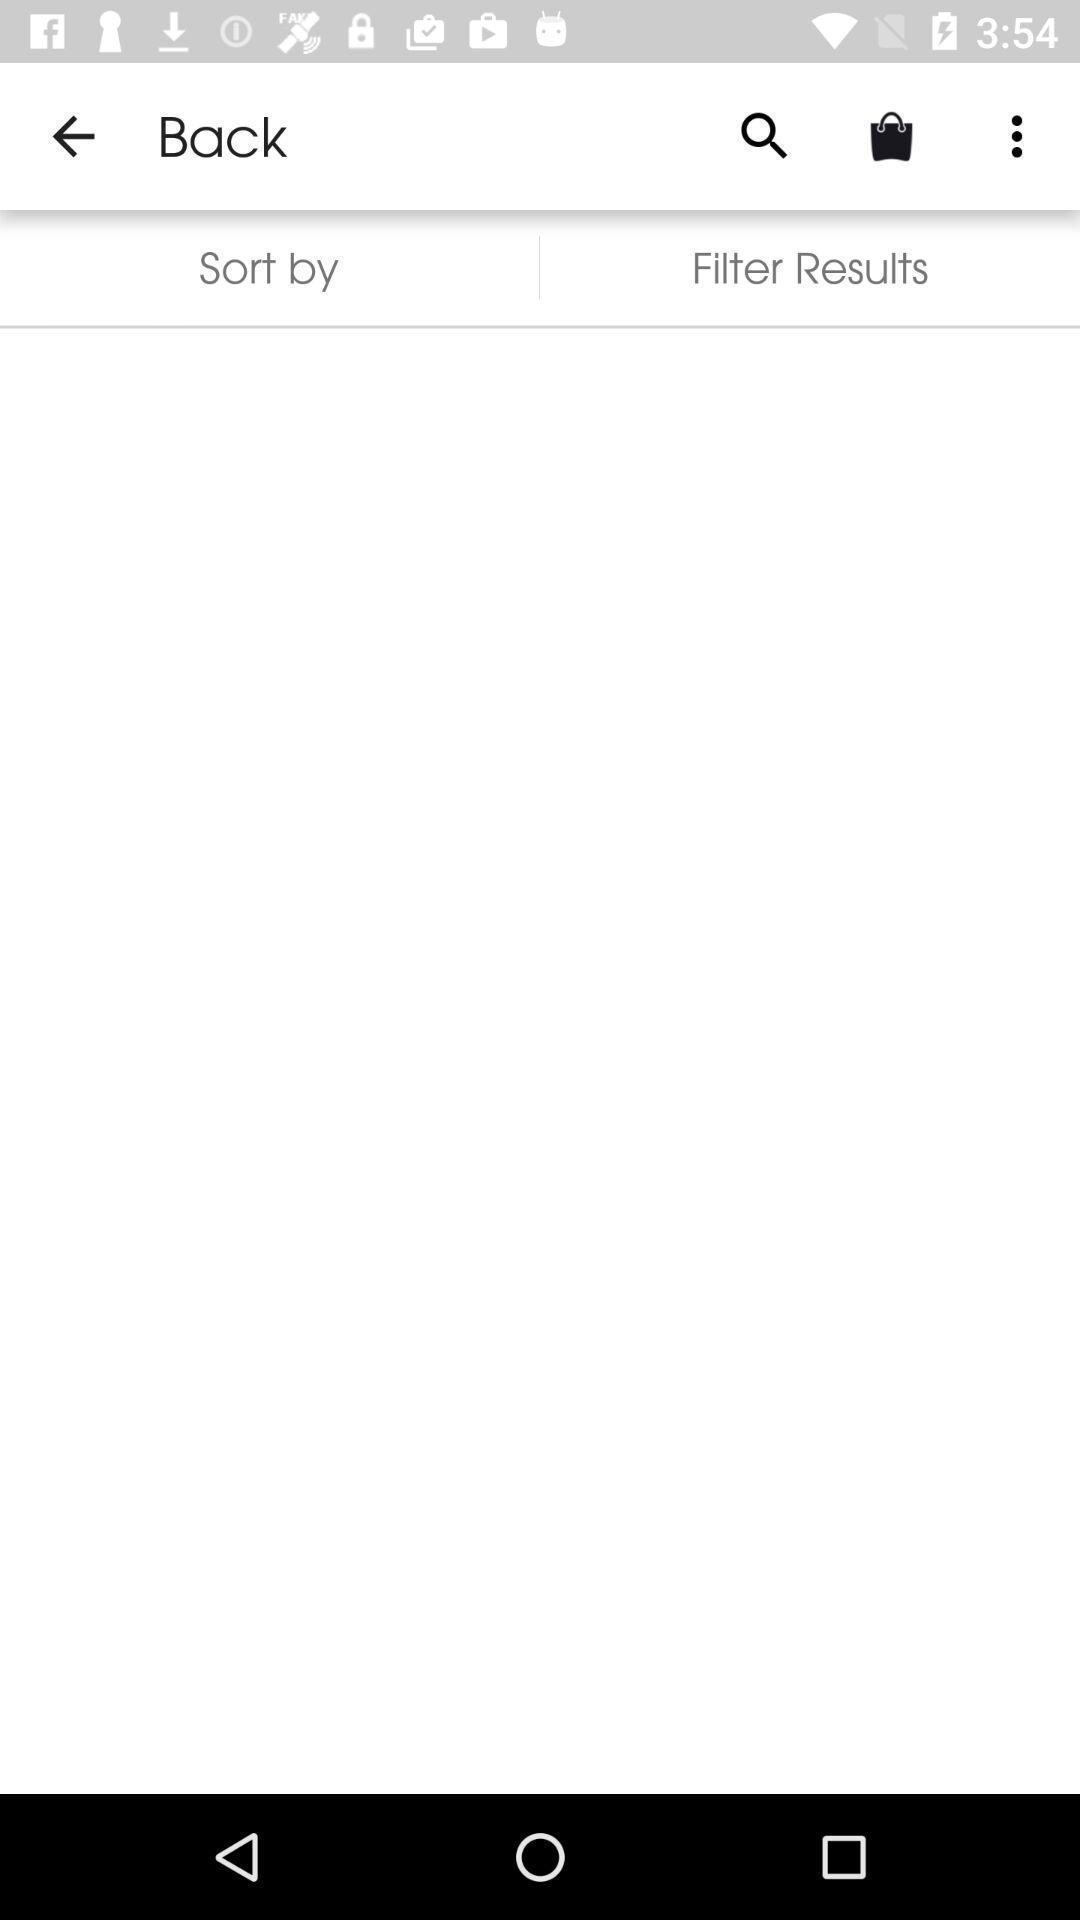Describe this image in words. Screen shows different options. 